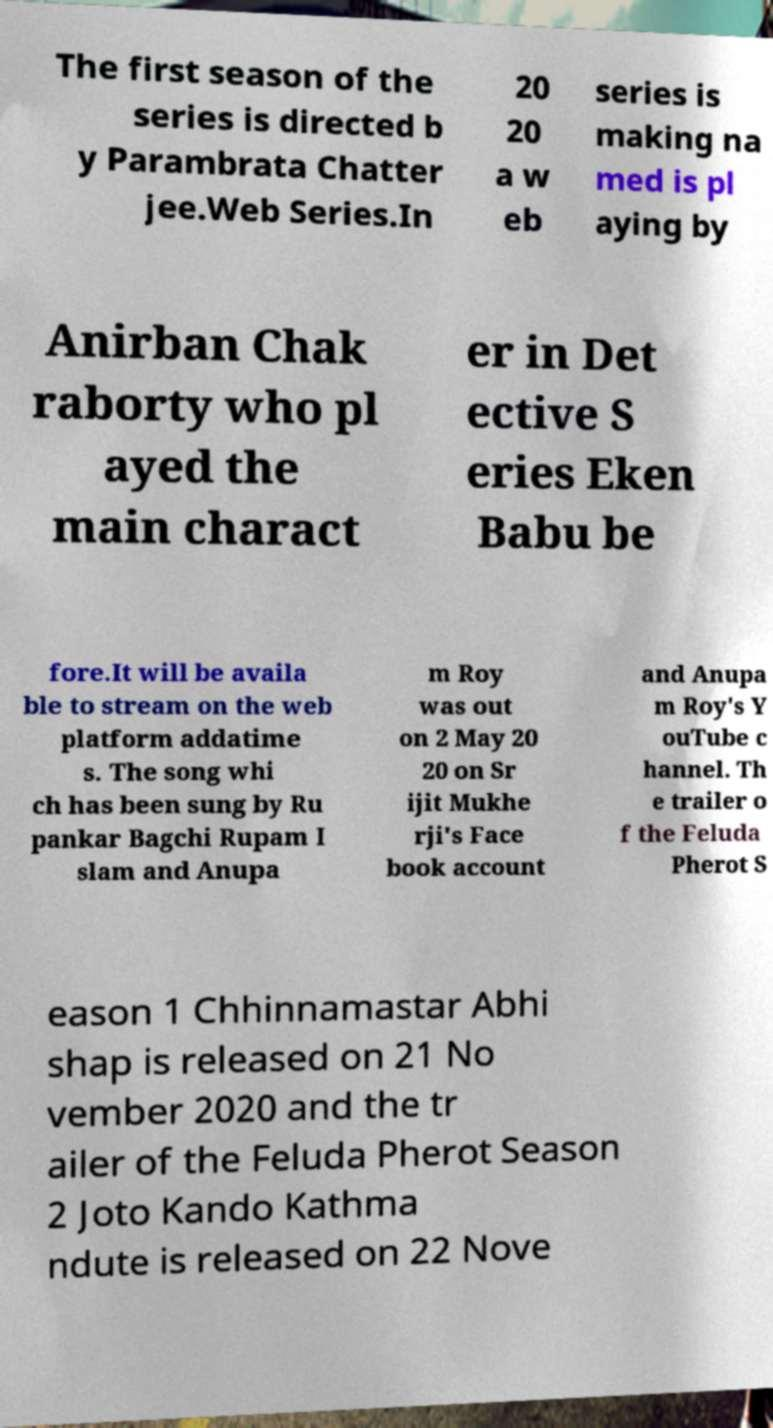Can you read and provide the text displayed in the image?This photo seems to have some interesting text. Can you extract and type it out for me? The first season of the series is directed b y Parambrata Chatter jee.Web Series.In 20 20 a w eb series is making na med is pl aying by Anirban Chak raborty who pl ayed the main charact er in Det ective S eries Eken Babu be fore.It will be availa ble to stream on the web platform addatime s. The song whi ch has been sung by Ru pankar Bagchi Rupam I slam and Anupa m Roy was out on 2 May 20 20 on Sr ijit Mukhe rji's Face book account and Anupa m Roy's Y ouTube c hannel. Th e trailer o f the Feluda Pherot S eason 1 Chhinnamastar Abhi shap is released on 21 No vember 2020 and the tr ailer of the Feluda Pherot Season 2 Joto Kando Kathma ndute is released on 22 Nove 